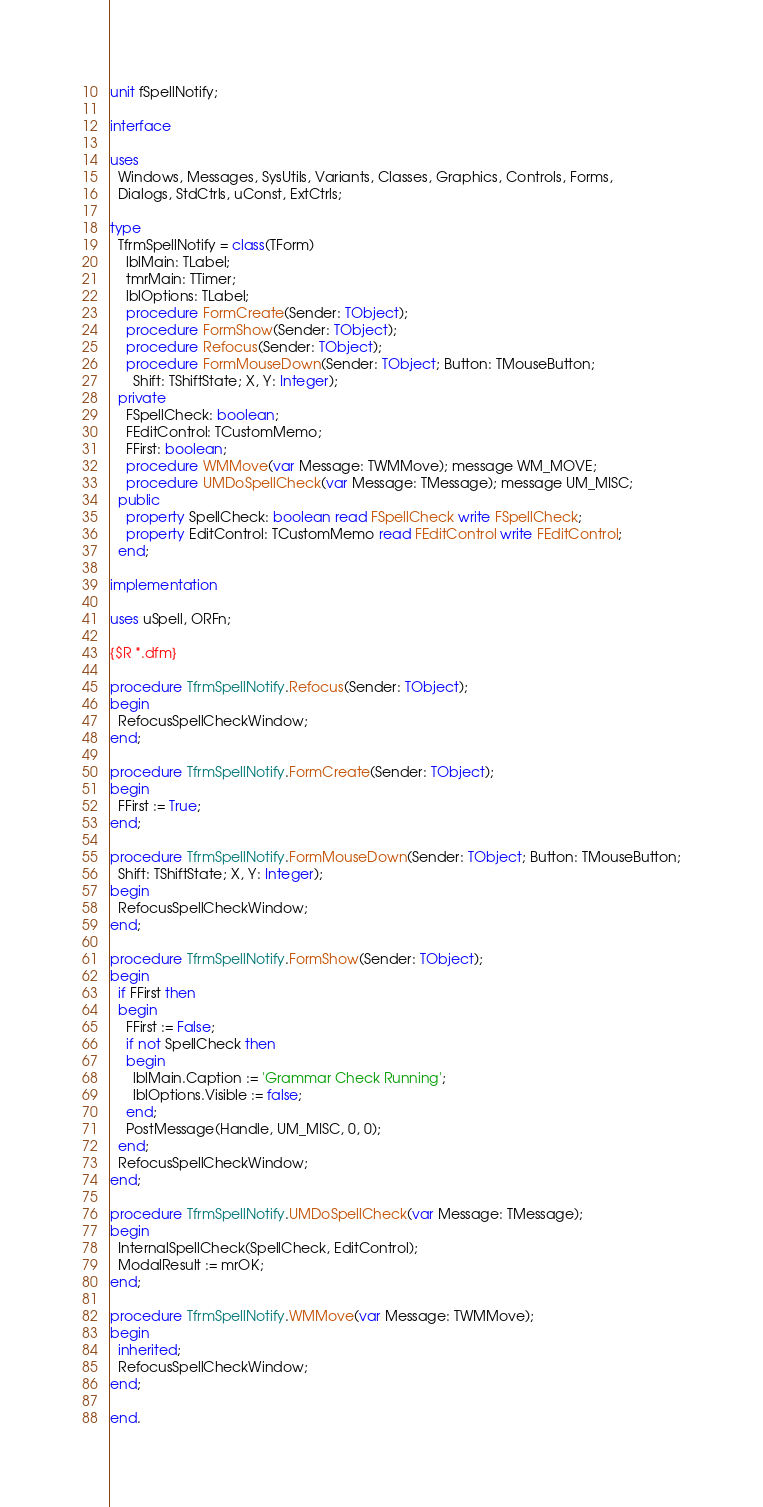Convert code to text. <code><loc_0><loc_0><loc_500><loc_500><_Pascal_>unit fSpellNotify;

interface

uses
  Windows, Messages, SysUtils, Variants, Classes, Graphics, Controls, Forms,
  Dialogs, StdCtrls, uConst, ExtCtrls;

type
  TfrmSpellNotify = class(TForm)
    lblMain: TLabel;
    tmrMain: TTimer;
    lblOptions: TLabel;
    procedure FormCreate(Sender: TObject);
    procedure FormShow(Sender: TObject);
    procedure Refocus(Sender: TObject);
    procedure FormMouseDown(Sender: TObject; Button: TMouseButton;
      Shift: TShiftState; X, Y: Integer);
  private
    FSpellCheck: boolean;
    FEditControl: TCustomMemo;
    FFirst: boolean;
    procedure WMMove(var Message: TWMMove); message WM_MOVE;    
    procedure UMDoSpellCheck(var Message: TMessage); message UM_MISC;
  public
    property SpellCheck: boolean read FSpellCheck write FSpellCheck;
    property EditControl: TCustomMemo read FEditControl write FEditControl;
  end;

implementation

uses uSpell, ORFn;

{$R *.dfm}

procedure TfrmSpellNotify.Refocus(Sender: TObject);
begin
  RefocusSpellCheckWindow;
end;

procedure TfrmSpellNotify.FormCreate(Sender: TObject);
begin
  FFirst := True;
end;

procedure TfrmSpellNotify.FormMouseDown(Sender: TObject; Button: TMouseButton;
  Shift: TShiftState; X, Y: Integer);
begin
  RefocusSpellCheckWindow;
end;

procedure TfrmSpellNotify.FormShow(Sender: TObject);
begin
  if FFirst then
  begin
    FFirst := False;
    if not SpellCheck then
    begin
      lblMain.Caption := 'Grammar Check Running';
      lblOptions.Visible := false;
    end;
    PostMessage(Handle, UM_MISC, 0, 0);
  end;
  RefocusSpellCheckWindow;
end;

procedure TfrmSpellNotify.UMDoSpellCheck(var Message: TMessage);
begin
  InternalSpellCheck(SpellCheck, EditControl);
  ModalResult := mrOK;
end;

procedure TfrmSpellNotify.WMMove(var Message: TWMMove);
begin
  inherited;
  RefocusSpellCheckWindow;
end;

end.
</code> 